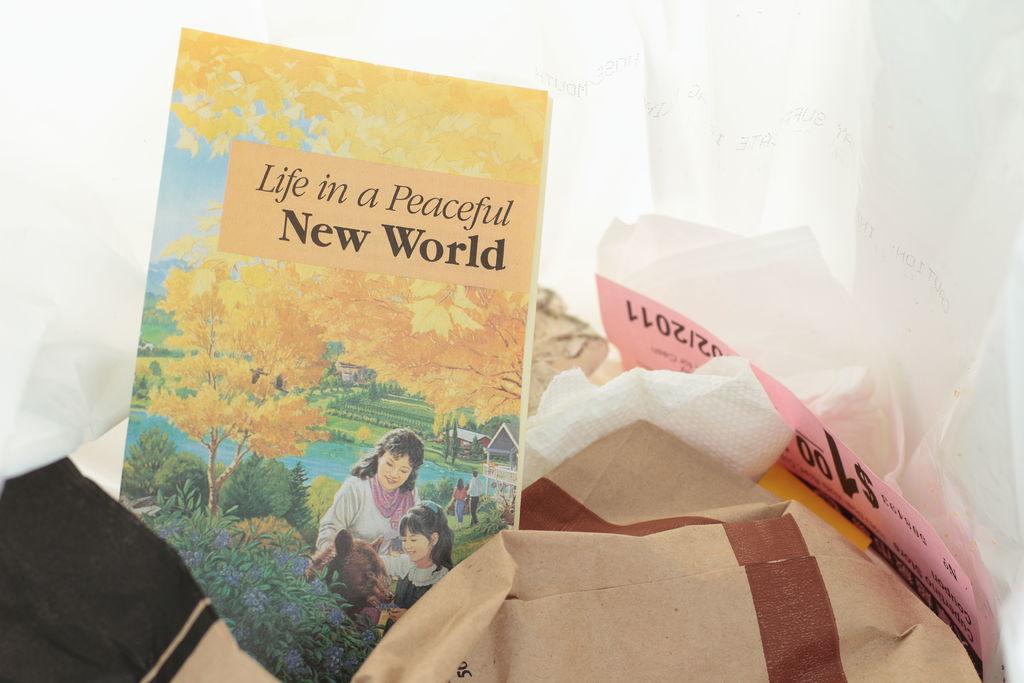What is the book about?
Offer a terse response. Life in a peaceful new world. What is the title of the book?
Your response must be concise. Life in a peaceful new world. 